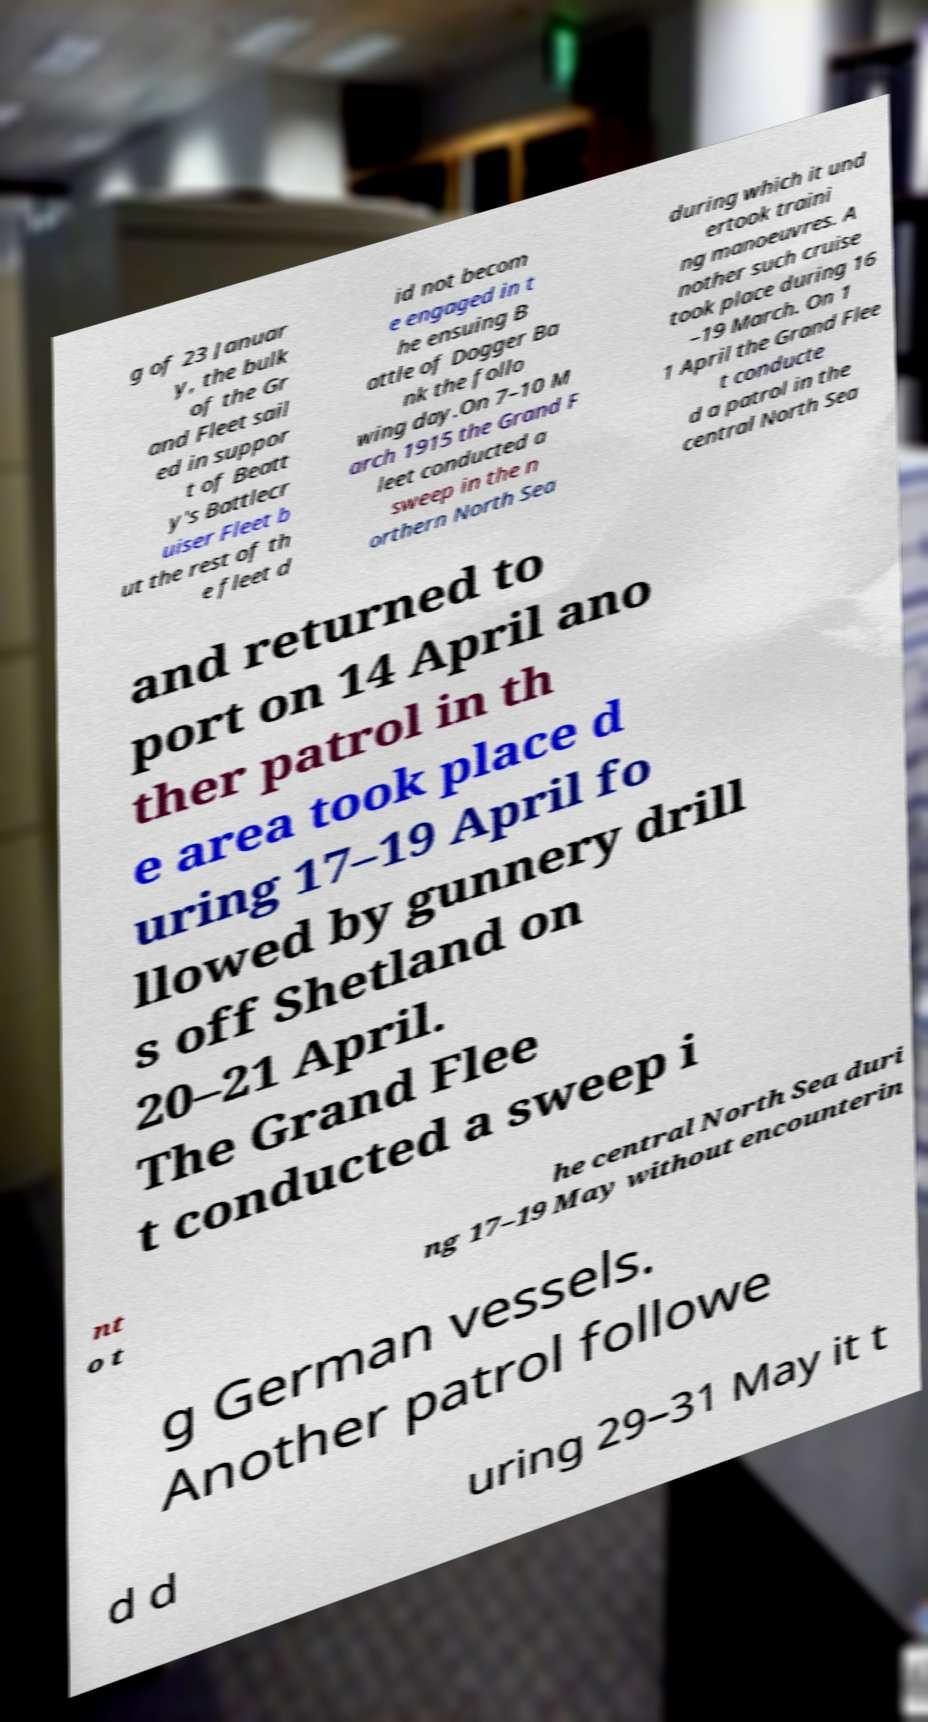Could you extract and type out the text from this image? g of 23 Januar y, the bulk of the Gr and Fleet sail ed in suppor t of Beatt y's Battlecr uiser Fleet b ut the rest of th e fleet d id not becom e engaged in t he ensuing B attle of Dogger Ba nk the follo wing day.On 7–10 M arch 1915 the Grand F leet conducted a sweep in the n orthern North Sea during which it und ertook traini ng manoeuvres. A nother such cruise took place during 16 –19 March. On 1 1 April the Grand Flee t conducte d a patrol in the central North Sea and returned to port on 14 April ano ther patrol in th e area took place d uring 17–19 April fo llowed by gunnery drill s off Shetland on 20–21 April. The Grand Flee t conducted a sweep i nt o t he central North Sea duri ng 17–19 May without encounterin g German vessels. Another patrol followe d d uring 29–31 May it t 